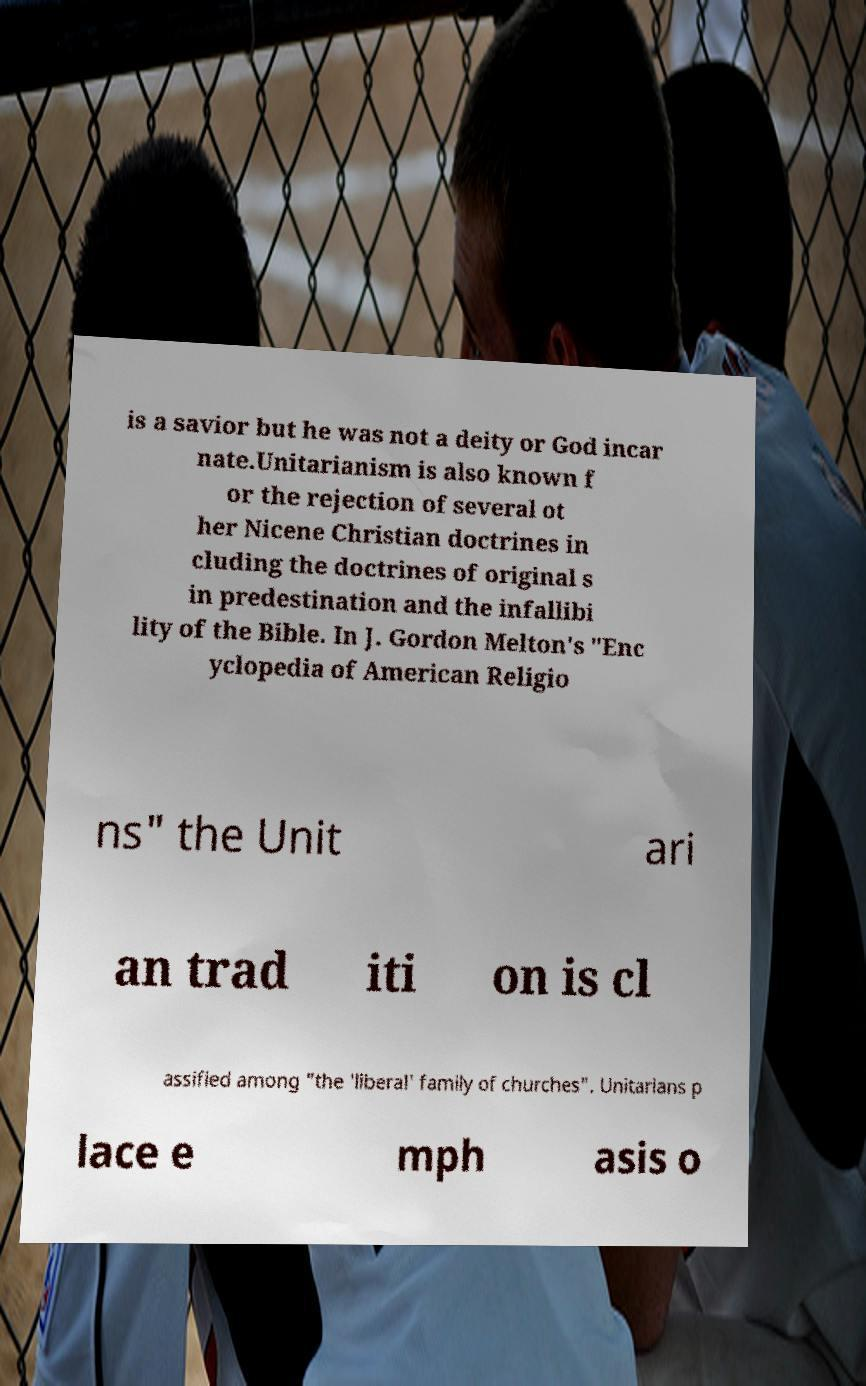Could you extract and type out the text from this image? is a savior but he was not a deity or God incar nate.Unitarianism is also known f or the rejection of several ot her Nicene Christian doctrines in cluding the doctrines of original s in predestination and the infallibi lity of the Bible. In J. Gordon Melton's "Enc yclopedia of American Religio ns" the Unit ari an trad iti on is cl assified among "the 'liberal' family of churches". Unitarians p lace e mph asis o 